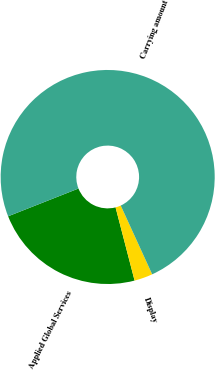Convert chart to OTSL. <chart><loc_0><loc_0><loc_500><loc_500><pie_chart><fcel>Applied Global Services<fcel>Display<fcel>Carrying amount<nl><fcel>23.06%<fcel>2.78%<fcel>74.15%<nl></chart> 